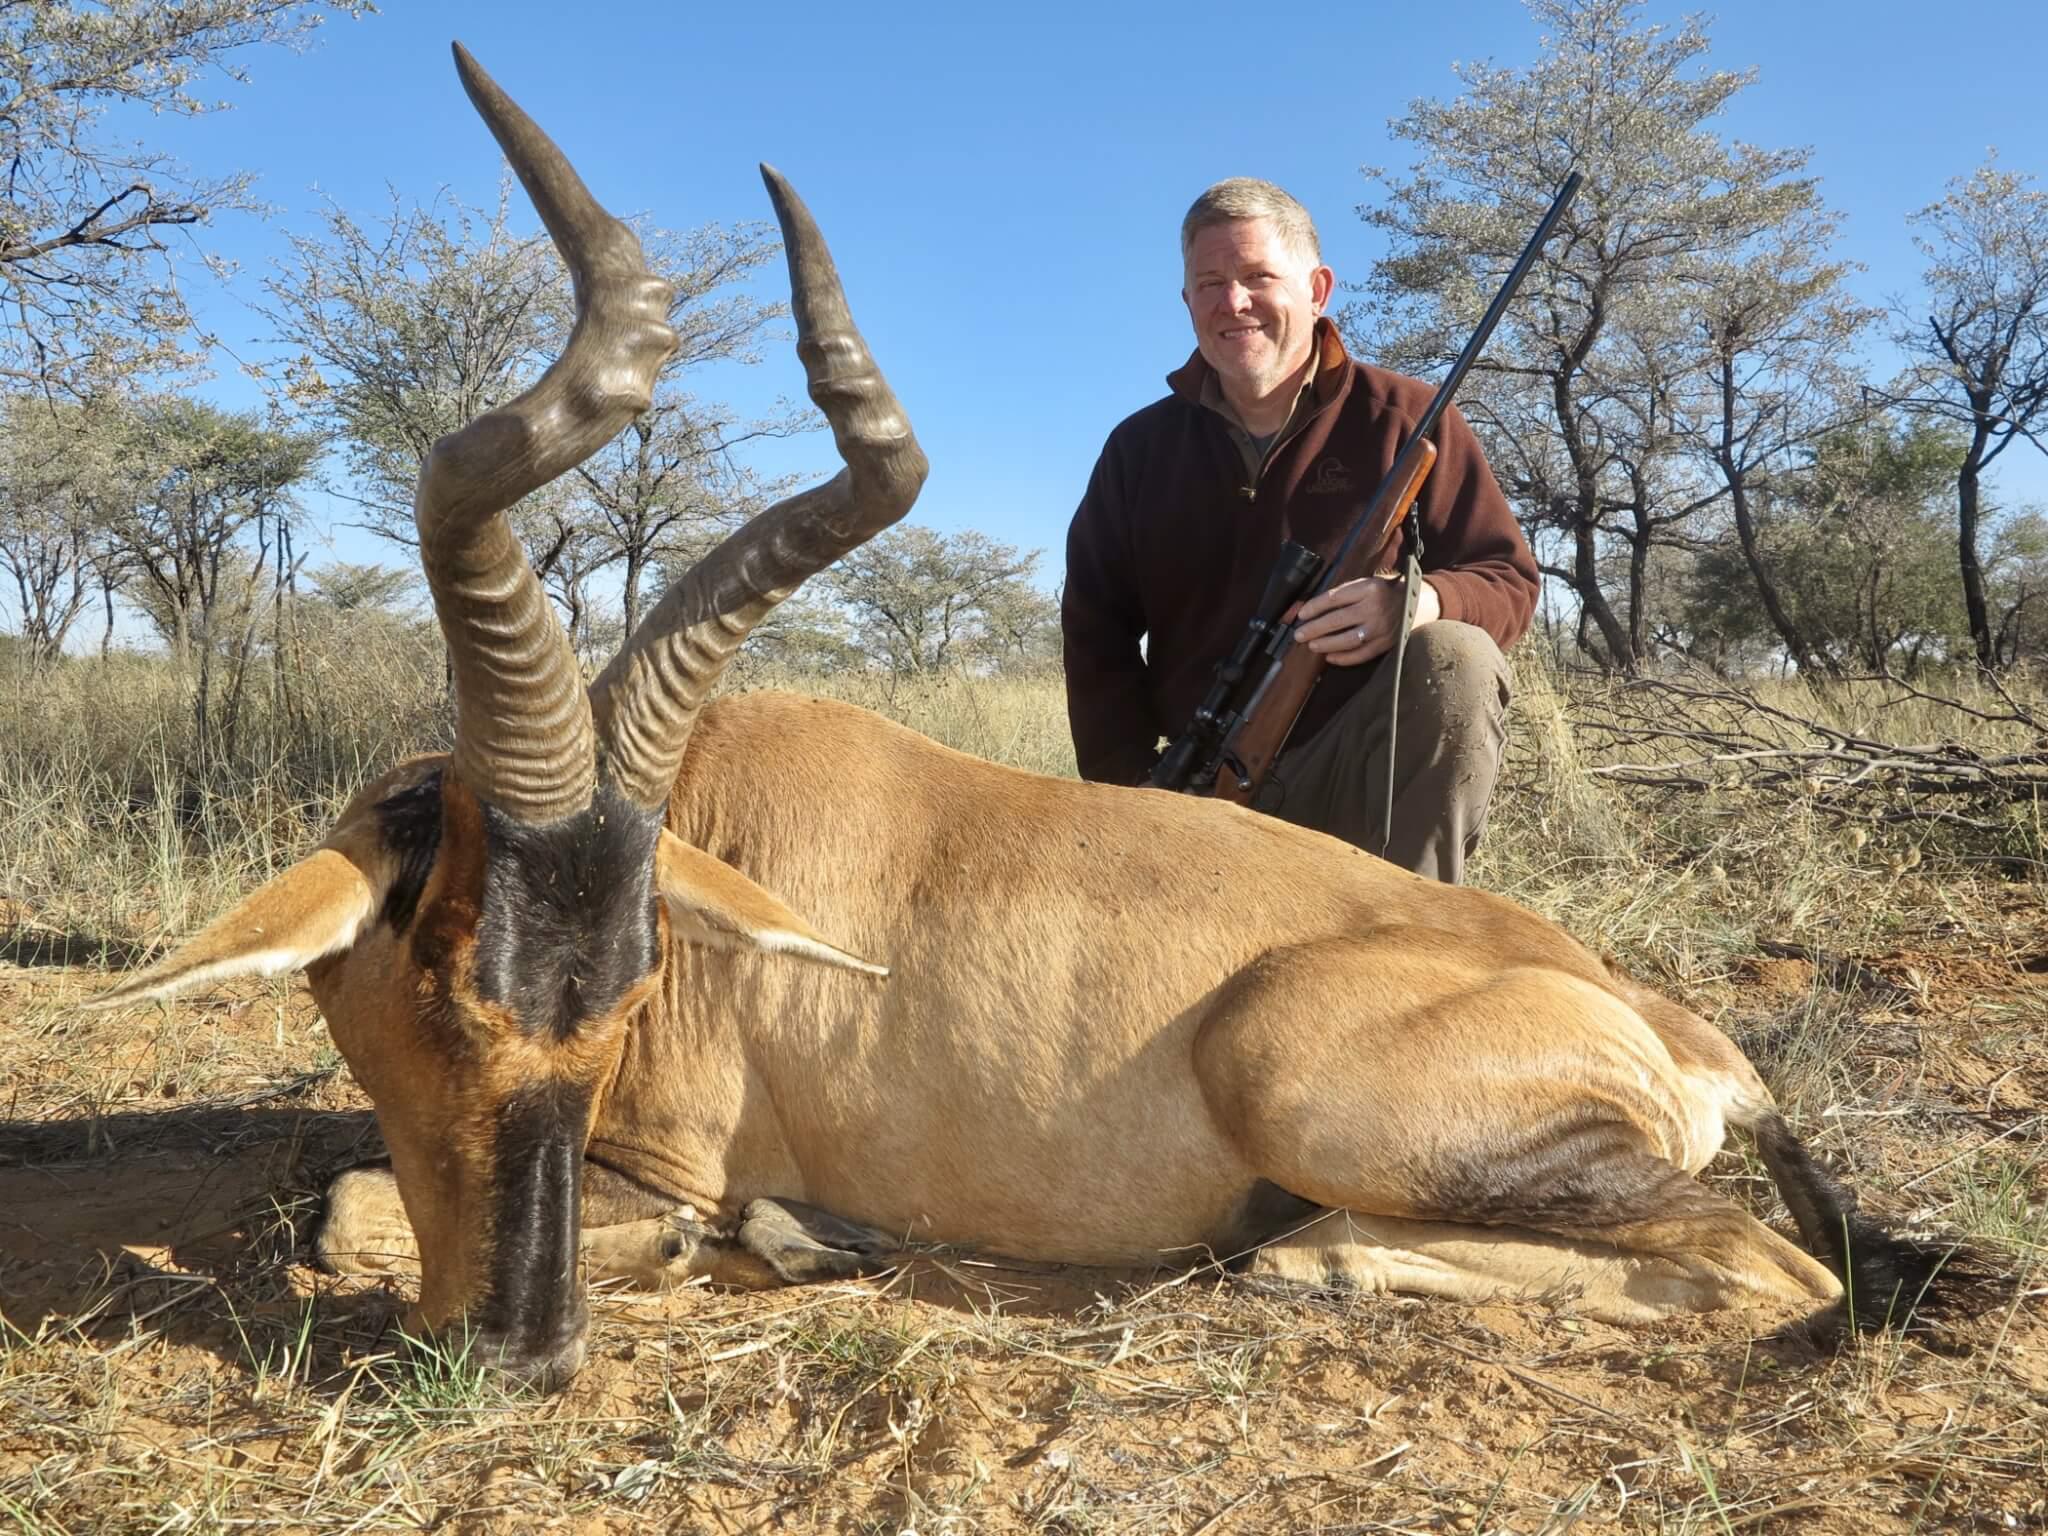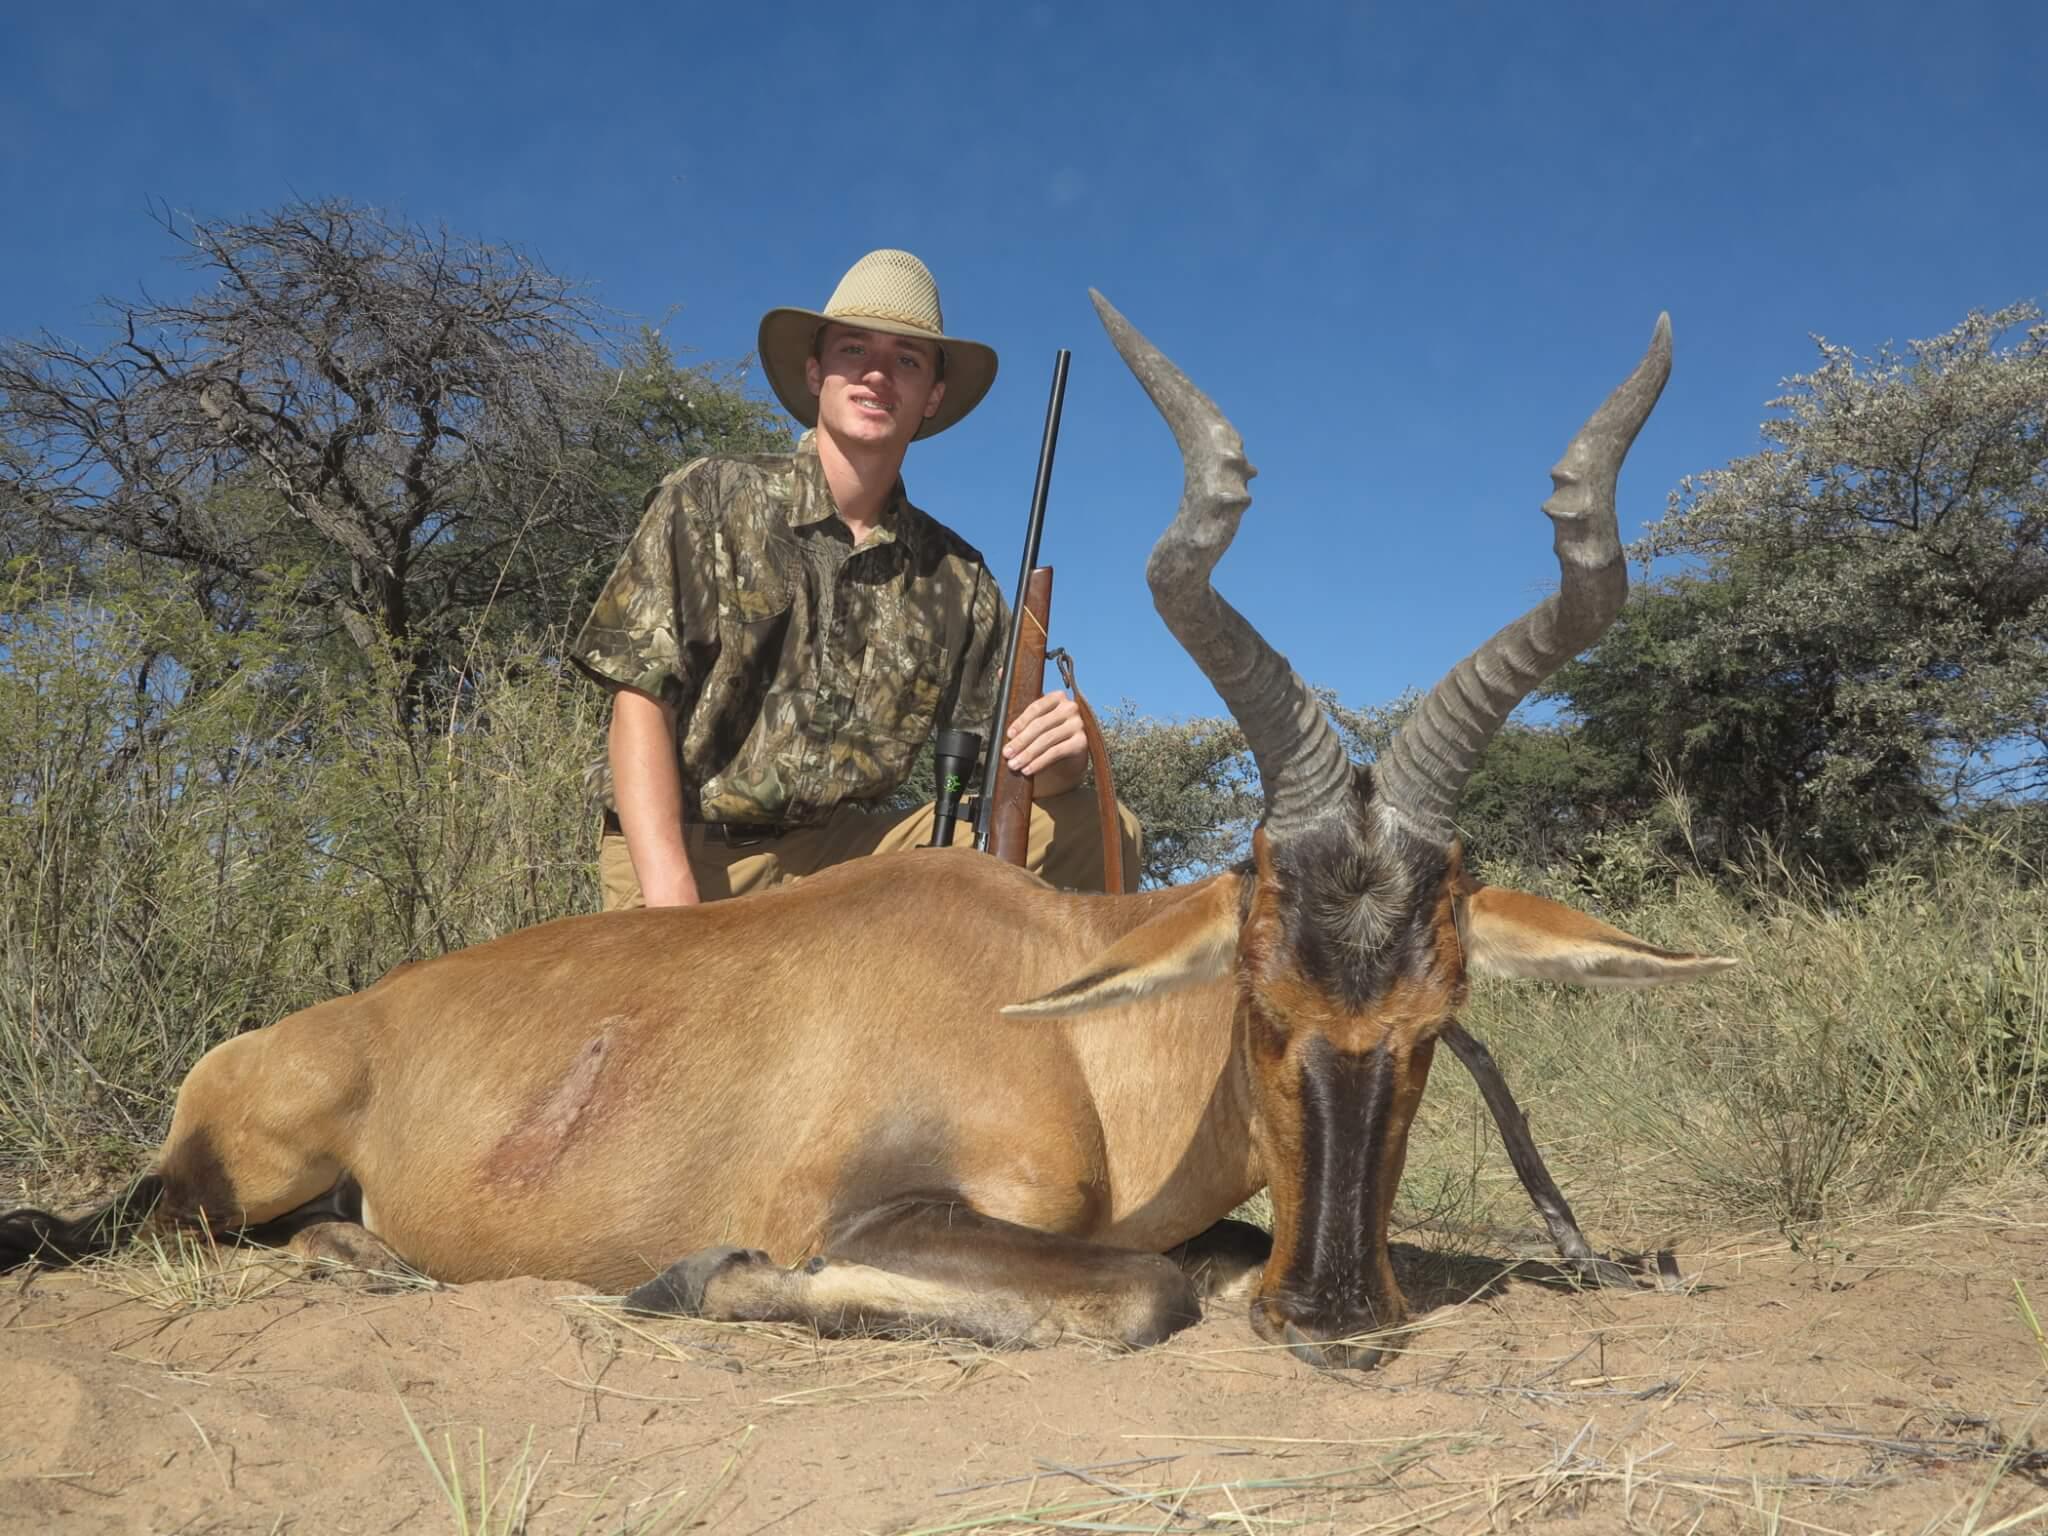The first image is the image on the left, the second image is the image on the right. Analyze the images presented: Is the assertion "In the right image, a hunter in a brimmed hat holding a rifle vertically is behind a downed horned animal with its head to the right." valid? Answer yes or no. Yes. The first image is the image on the left, the second image is the image on the right. Given the left and right images, does the statement "There are exactly two men." hold true? Answer yes or no. Yes. 